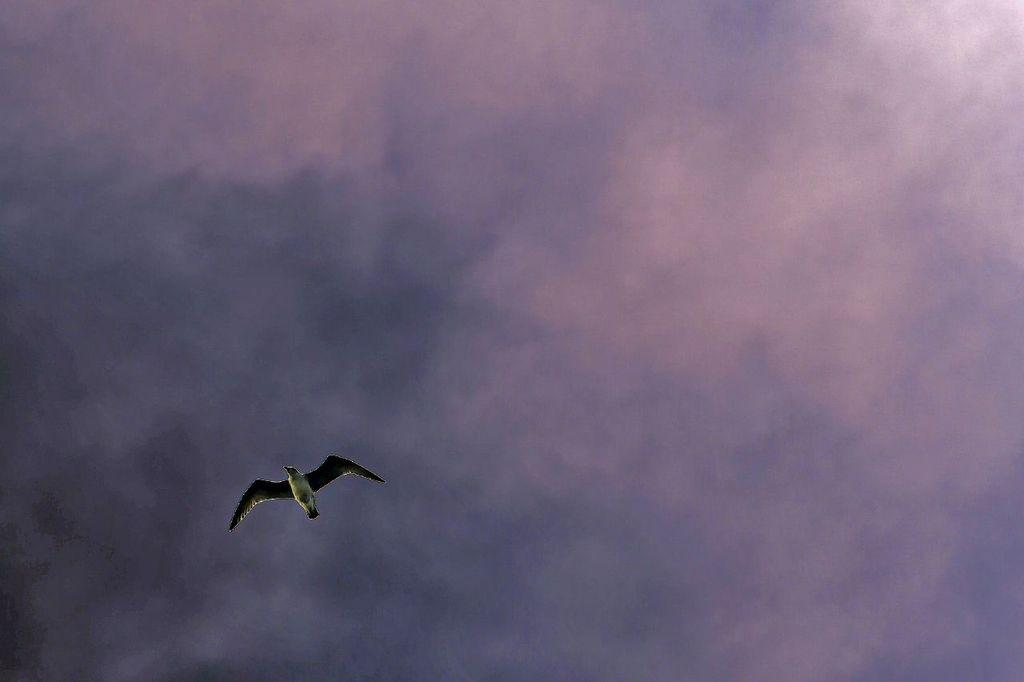What type of animal can be seen in the image? There is a bird in the image. What is the bird doing in the image? The bird is flying in the sky. What type of jewel is the bird holding in its beak in the image? There is no jewel present in the image; the bird is simply flying in the sky. 